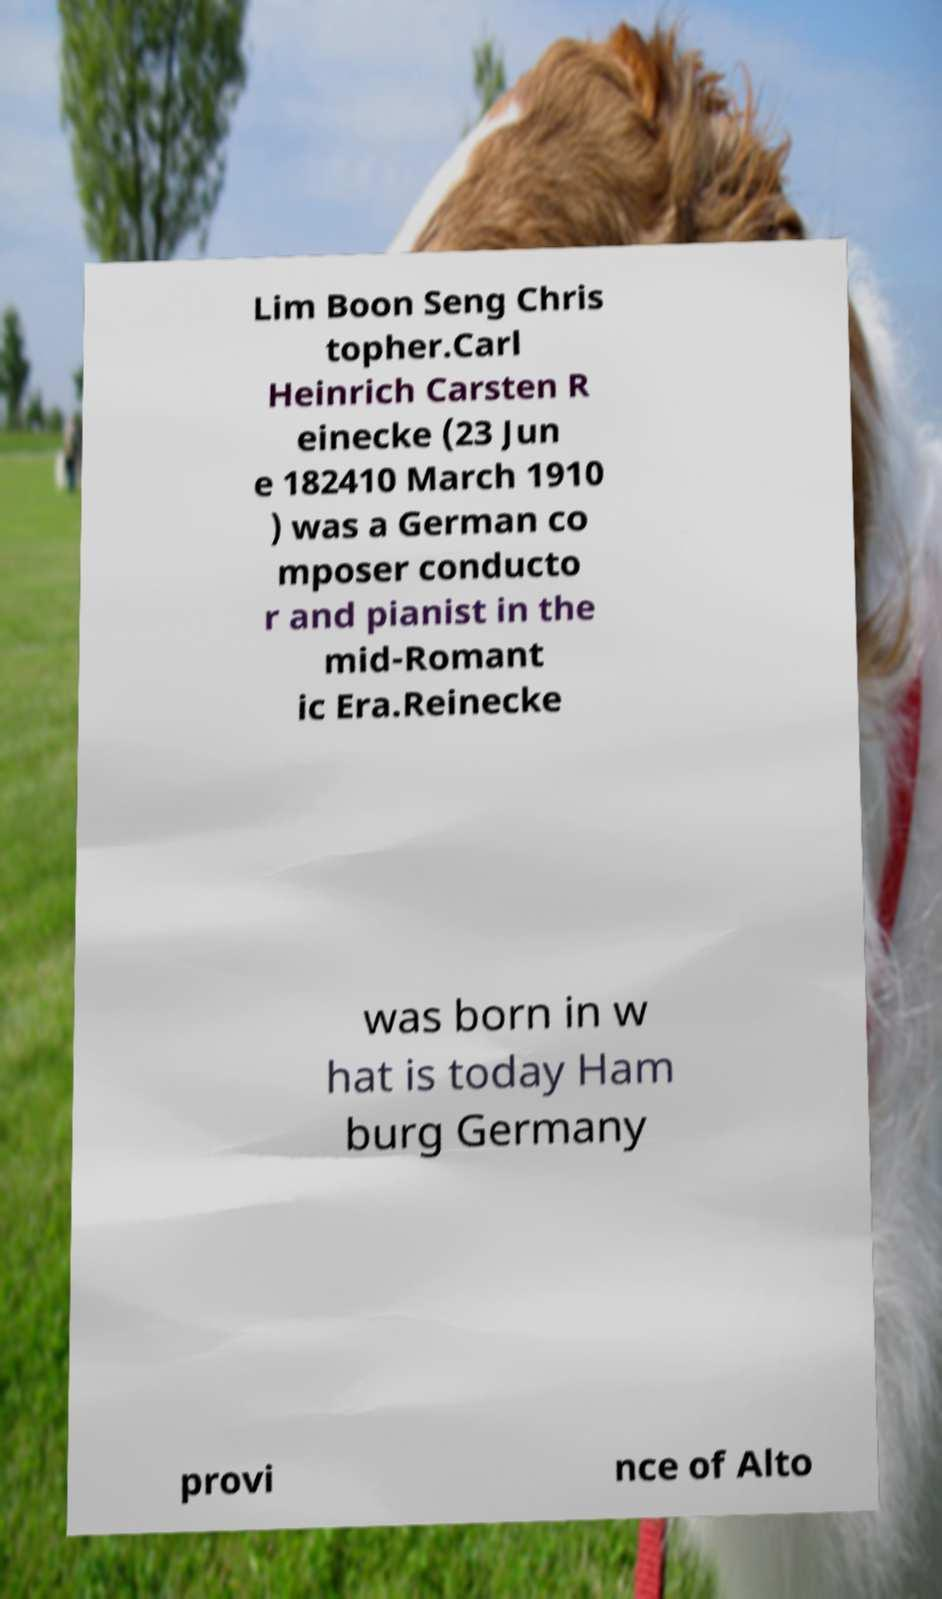There's text embedded in this image that I need extracted. Can you transcribe it verbatim? Lim Boon Seng Chris topher.Carl Heinrich Carsten R einecke (23 Jun e 182410 March 1910 ) was a German co mposer conducto r and pianist in the mid-Romant ic Era.Reinecke was born in w hat is today Ham burg Germany provi nce of Alto 